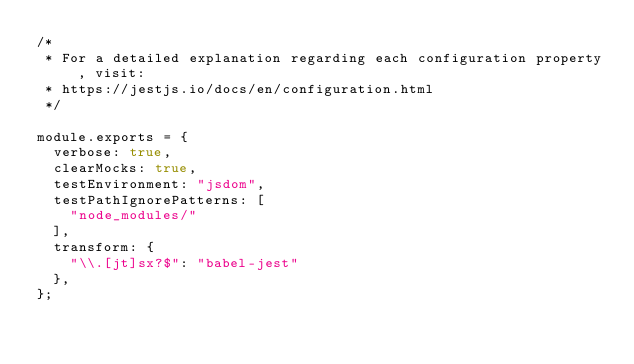Convert code to text. <code><loc_0><loc_0><loc_500><loc_500><_JavaScript_>/*
 * For a detailed explanation regarding each configuration property, visit:
 * https://jestjs.io/docs/en/configuration.html
 */

module.exports = {
	verbose: true,
  clearMocks: true,
  testEnvironment: "jsdom",
  testPathIgnorePatterns: [
    "node_modules/"
  ],
  transform: {
		"\\.[jt]sx?$": "babel-jest"
	},
};
</code> 